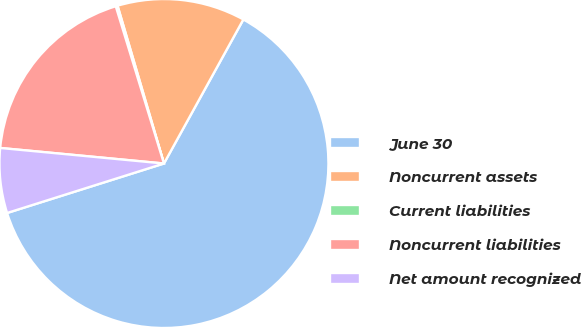<chart> <loc_0><loc_0><loc_500><loc_500><pie_chart><fcel>June 30<fcel>Noncurrent assets<fcel>Current liabilities<fcel>Noncurrent liabilities<fcel>Net amount recognized<nl><fcel>62.11%<fcel>12.57%<fcel>0.18%<fcel>18.76%<fcel>6.37%<nl></chart> 